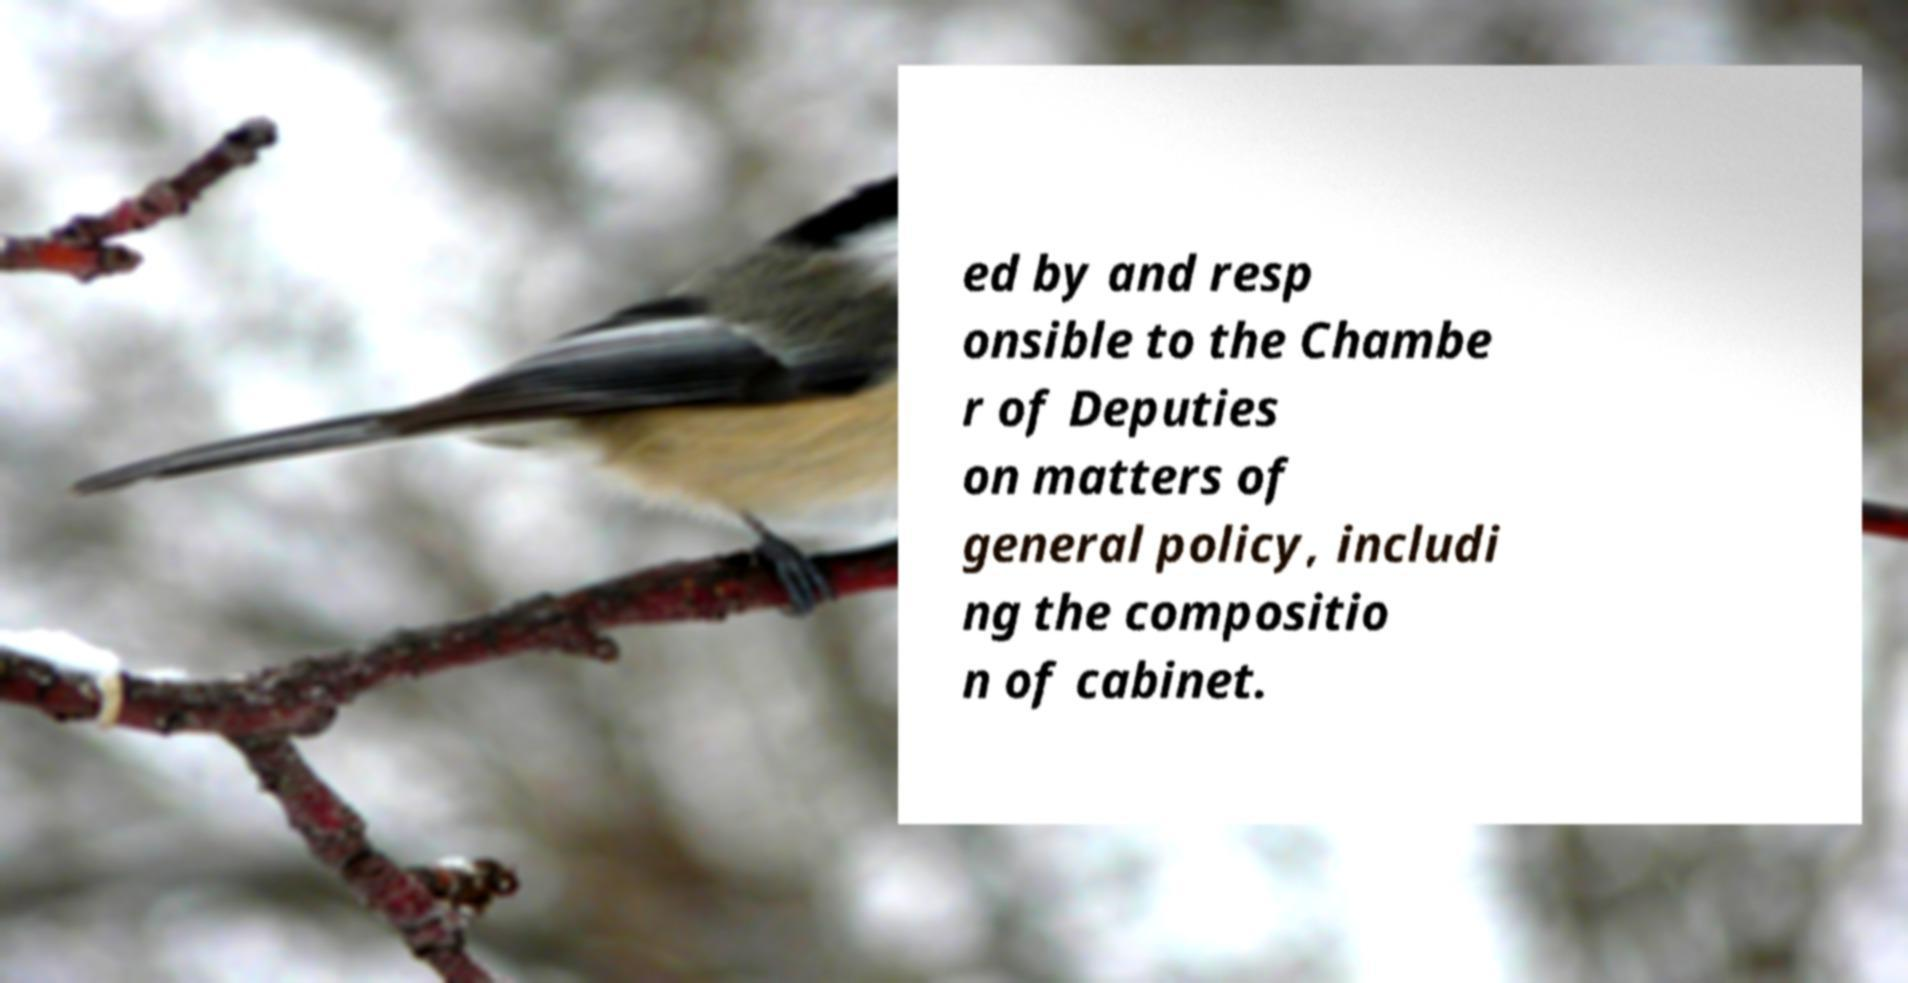Can you read and provide the text displayed in the image?This photo seems to have some interesting text. Can you extract and type it out for me? ed by and resp onsible to the Chambe r of Deputies on matters of general policy, includi ng the compositio n of cabinet. 